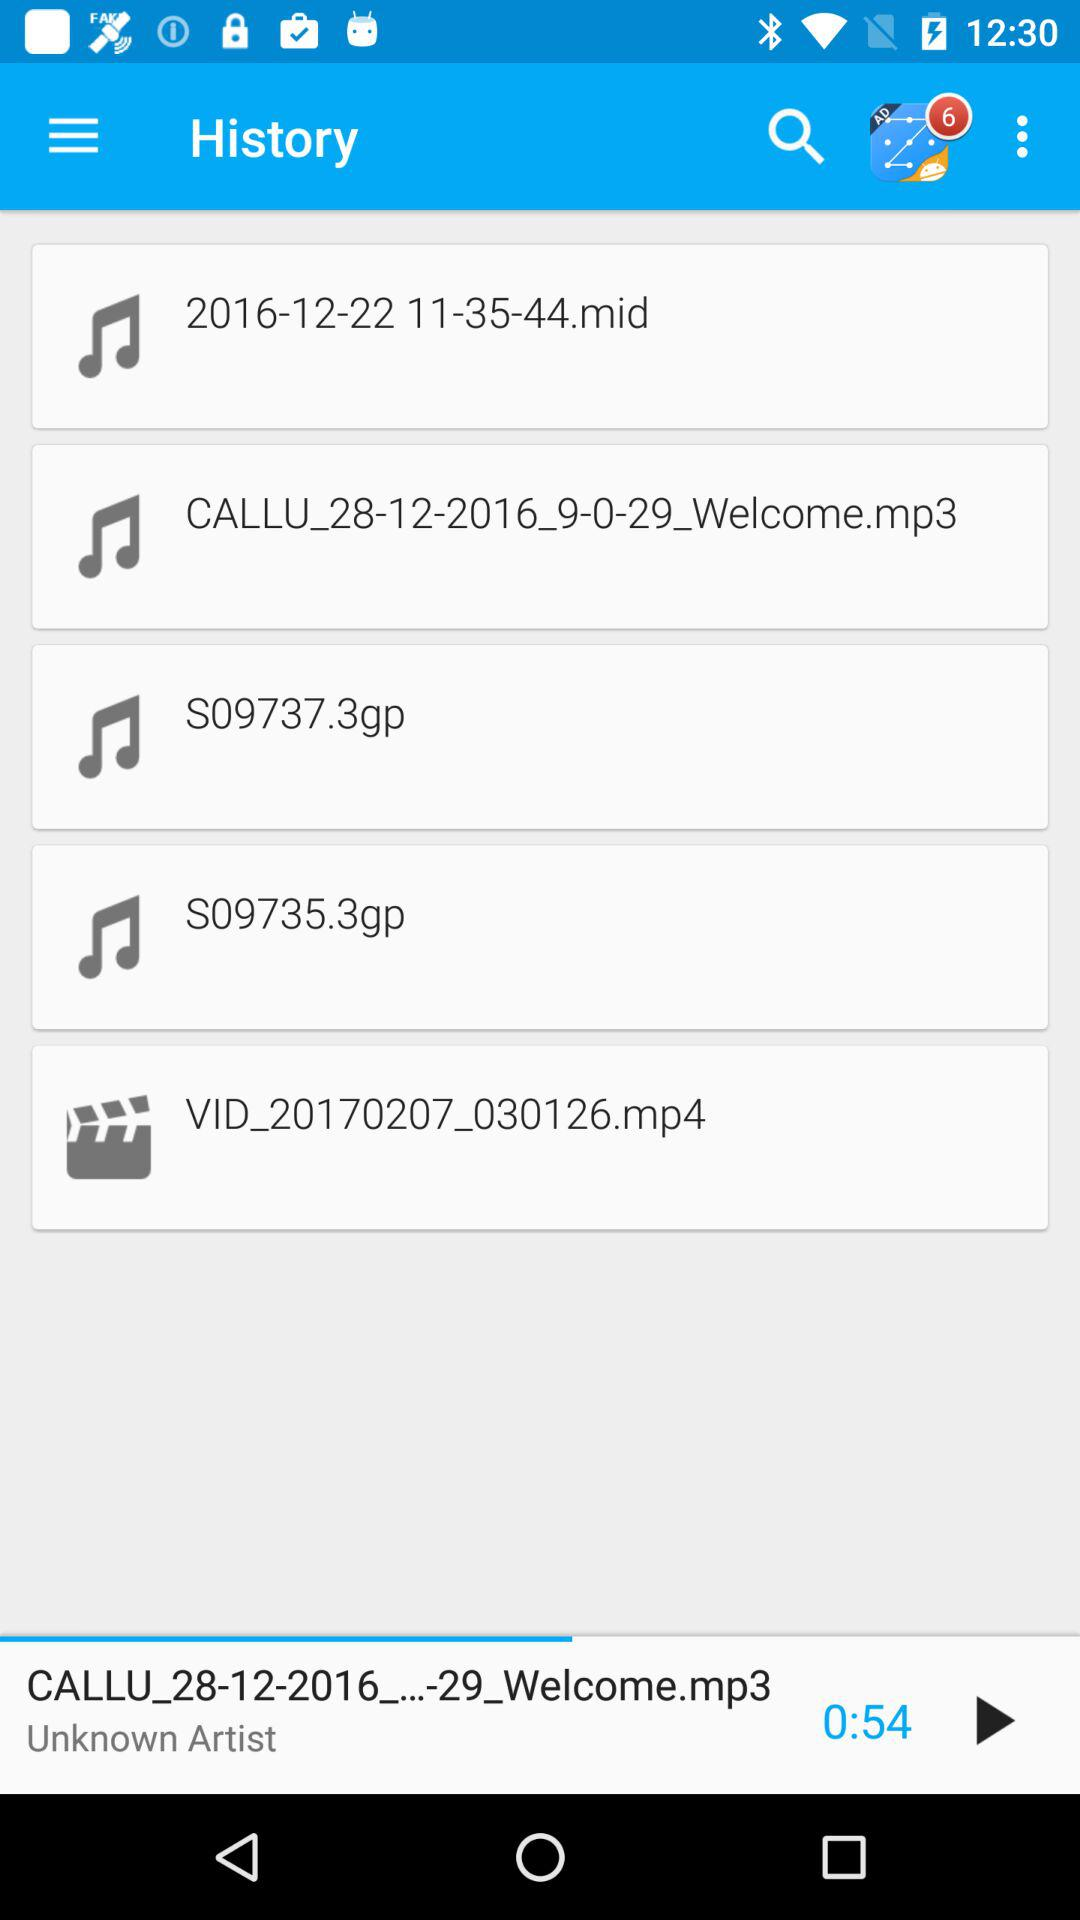How much duration left for the playing audio?
When the provided information is insufficient, respond with <no answer>. <no answer> 